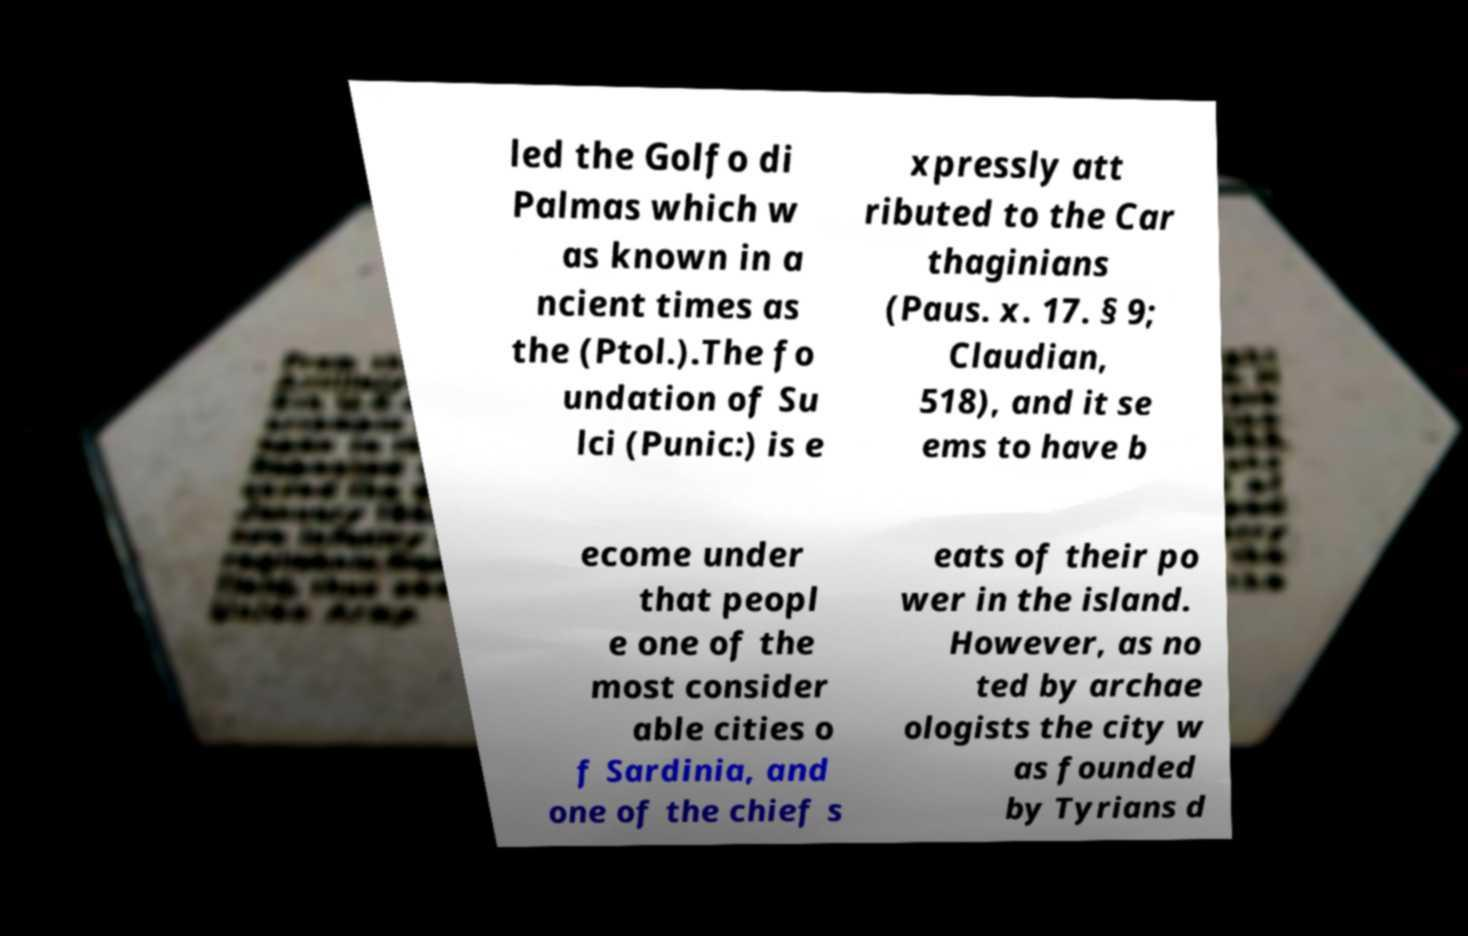I need the written content from this picture converted into text. Can you do that? led the Golfo di Palmas which w as known in a ncient times as the (Ptol.).The fo undation of Su lci (Punic:) is e xpressly att ributed to the Car thaginians (Paus. x. 17. § 9; Claudian, 518), and it se ems to have b ecome under that peopl e one of the most consider able cities o f Sardinia, and one of the chief s eats of their po wer in the island. However, as no ted by archae ologists the city w as founded by Tyrians d 